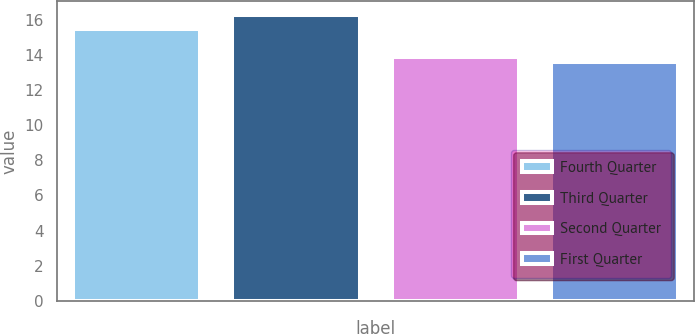Convert chart. <chart><loc_0><loc_0><loc_500><loc_500><bar_chart><fcel>Fourth Quarter<fcel>Third Quarter<fcel>Second Quarter<fcel>First Quarter<nl><fcel>15.5<fcel>16.25<fcel>13.86<fcel>13.59<nl></chart> 